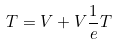<formula> <loc_0><loc_0><loc_500><loc_500>T = V + V \frac { 1 } { e } T</formula> 